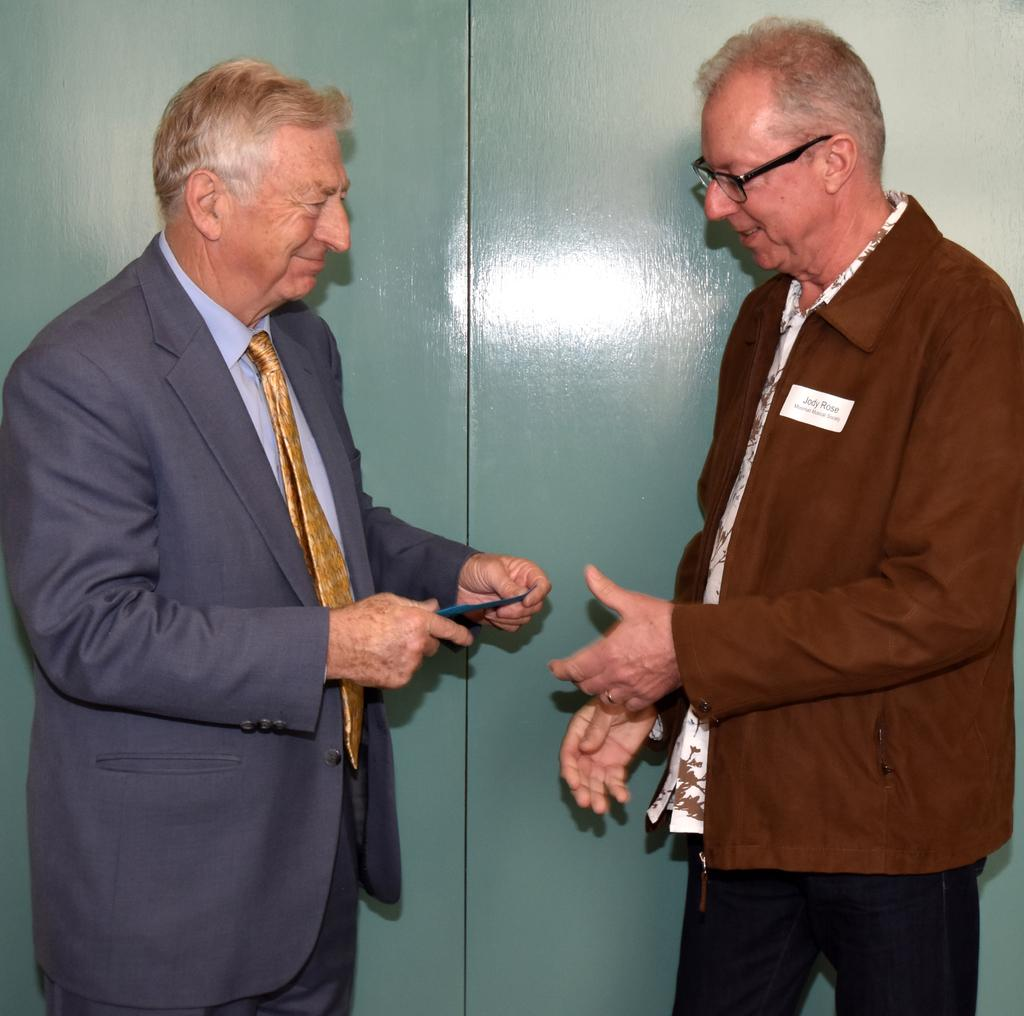How many people are present in the image? There are two people standing in the image. What is the man on the left holding in his hand? The man on the left is holding a card in his hand. What can be seen in the background of the image? There is a wall in the background of the image. What type of sponge is being used to clean the wall in the image? There is no sponge present in the image, and the wall is not being cleaned. 